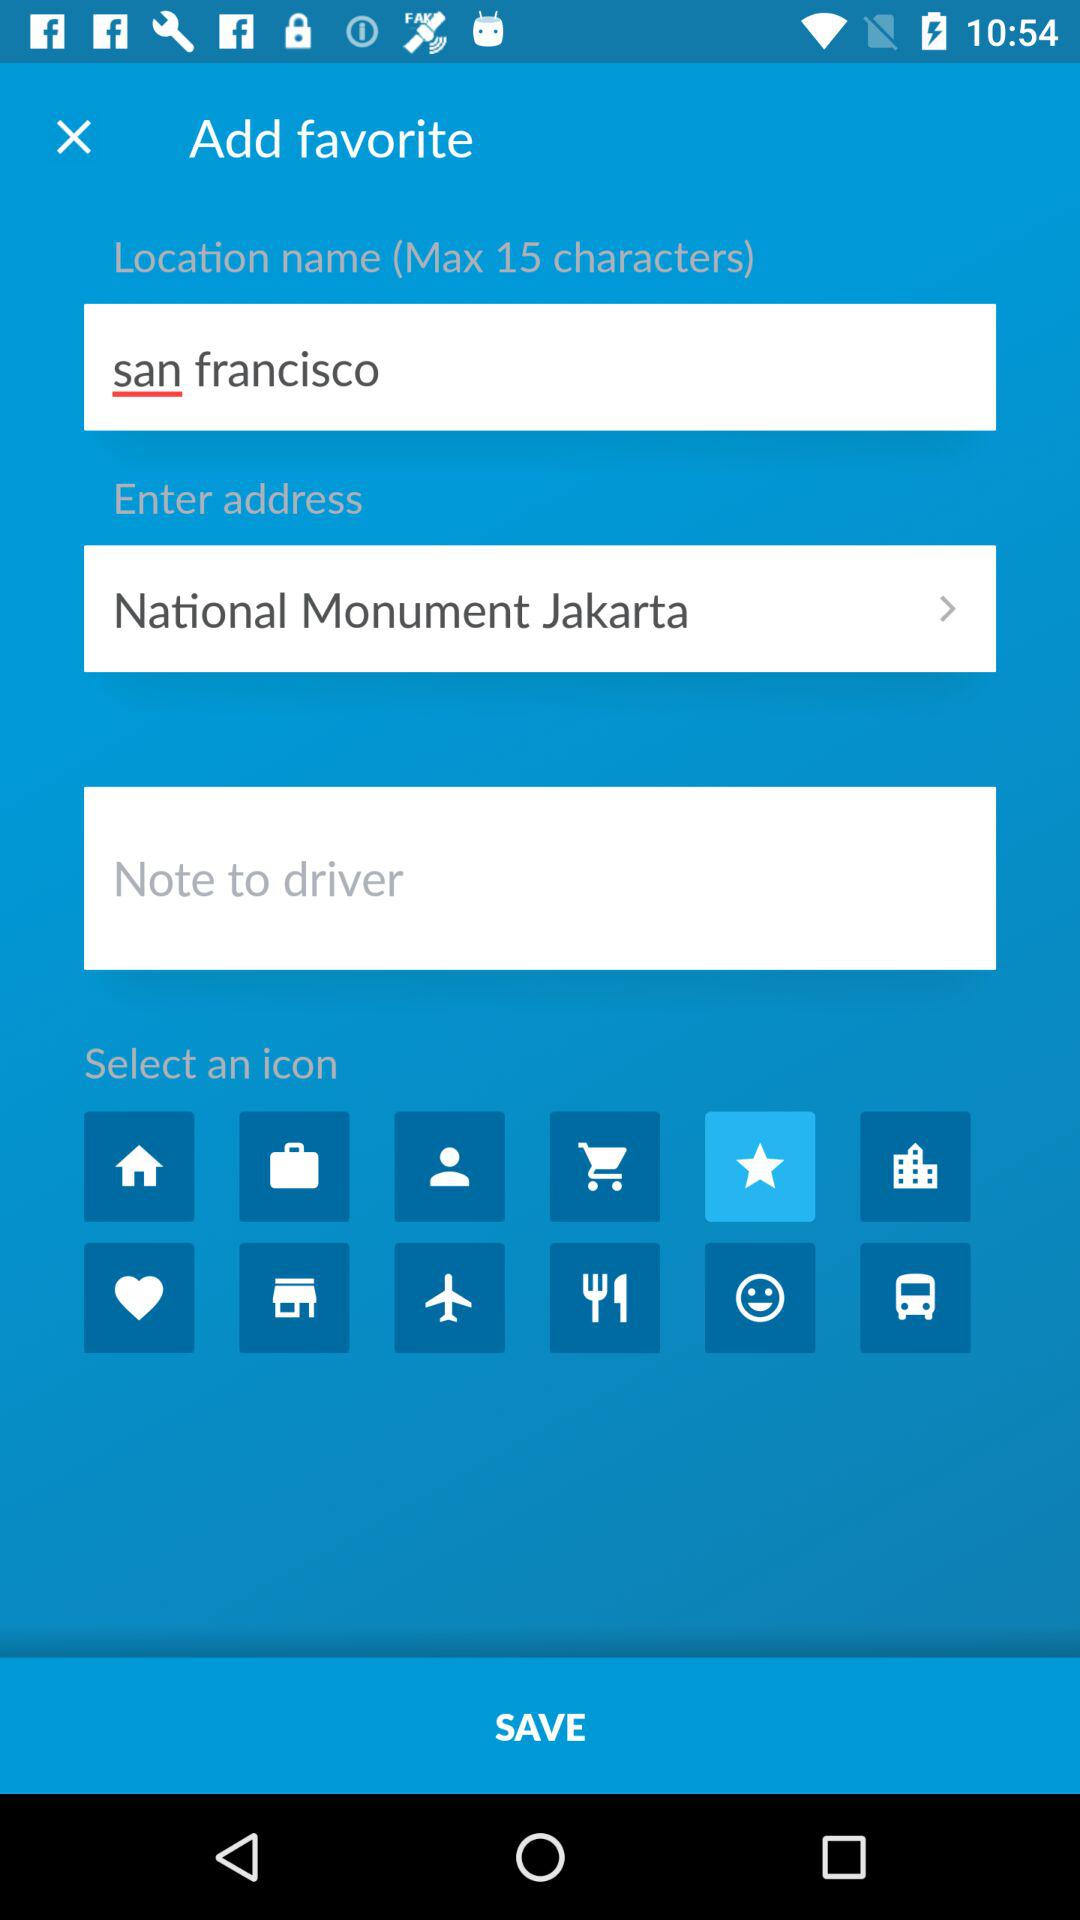What is the location name? The location name is San Francisco. 